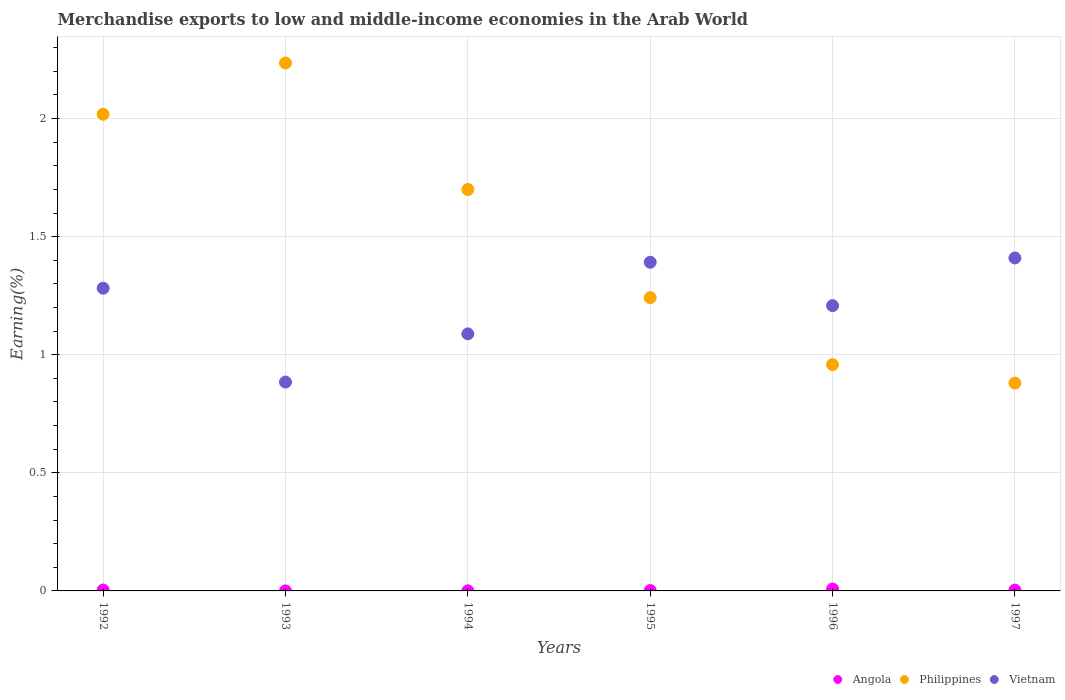How many different coloured dotlines are there?
Provide a succinct answer. 3. What is the percentage of amount earned from merchandise exports in Philippines in 1994?
Give a very brief answer. 1.7. Across all years, what is the maximum percentage of amount earned from merchandise exports in Angola?
Provide a succinct answer. 0.01. Across all years, what is the minimum percentage of amount earned from merchandise exports in Philippines?
Your response must be concise. 0.88. In which year was the percentage of amount earned from merchandise exports in Vietnam maximum?
Ensure brevity in your answer.  1997. What is the total percentage of amount earned from merchandise exports in Angola in the graph?
Offer a very short reply. 0.02. What is the difference between the percentage of amount earned from merchandise exports in Angola in 1992 and that in 1995?
Your response must be concise. 0. What is the difference between the percentage of amount earned from merchandise exports in Angola in 1993 and the percentage of amount earned from merchandise exports in Philippines in 1997?
Provide a short and direct response. -0.88. What is the average percentage of amount earned from merchandise exports in Vietnam per year?
Your answer should be compact. 1.21. In the year 1994, what is the difference between the percentage of amount earned from merchandise exports in Angola and percentage of amount earned from merchandise exports in Philippines?
Keep it short and to the point. -1.7. In how many years, is the percentage of amount earned from merchandise exports in Philippines greater than 1.8 %?
Provide a short and direct response. 2. What is the ratio of the percentage of amount earned from merchandise exports in Philippines in 1994 to that in 1995?
Keep it short and to the point. 1.37. Is the difference between the percentage of amount earned from merchandise exports in Angola in 1992 and 1993 greater than the difference between the percentage of amount earned from merchandise exports in Philippines in 1992 and 1993?
Your answer should be compact. Yes. What is the difference between the highest and the second highest percentage of amount earned from merchandise exports in Vietnam?
Keep it short and to the point. 0.02. What is the difference between the highest and the lowest percentage of amount earned from merchandise exports in Angola?
Ensure brevity in your answer.  0.01. In how many years, is the percentage of amount earned from merchandise exports in Vietnam greater than the average percentage of amount earned from merchandise exports in Vietnam taken over all years?
Provide a short and direct response. 3. Does the percentage of amount earned from merchandise exports in Angola monotonically increase over the years?
Ensure brevity in your answer.  No. Is the percentage of amount earned from merchandise exports in Angola strictly greater than the percentage of amount earned from merchandise exports in Philippines over the years?
Provide a short and direct response. No. How many dotlines are there?
Your answer should be very brief. 3. Does the graph contain any zero values?
Give a very brief answer. No. How many legend labels are there?
Provide a succinct answer. 3. What is the title of the graph?
Ensure brevity in your answer.  Merchandise exports to low and middle-income economies in the Arab World. What is the label or title of the Y-axis?
Provide a succinct answer. Earning(%). What is the Earning(%) in Angola in 1992?
Make the answer very short. 0. What is the Earning(%) in Philippines in 1992?
Offer a very short reply. 2.02. What is the Earning(%) of Vietnam in 1992?
Offer a very short reply. 1.28. What is the Earning(%) of Angola in 1993?
Give a very brief answer. 0. What is the Earning(%) of Philippines in 1993?
Give a very brief answer. 2.24. What is the Earning(%) of Vietnam in 1993?
Your response must be concise. 0.88. What is the Earning(%) of Angola in 1994?
Make the answer very short. 0. What is the Earning(%) in Philippines in 1994?
Offer a very short reply. 1.7. What is the Earning(%) in Vietnam in 1994?
Your answer should be very brief. 1.09. What is the Earning(%) in Angola in 1995?
Your response must be concise. 0. What is the Earning(%) in Philippines in 1995?
Provide a short and direct response. 1.24. What is the Earning(%) in Vietnam in 1995?
Your response must be concise. 1.39. What is the Earning(%) of Angola in 1996?
Give a very brief answer. 0.01. What is the Earning(%) of Philippines in 1996?
Provide a succinct answer. 0.96. What is the Earning(%) in Vietnam in 1996?
Your response must be concise. 1.21. What is the Earning(%) in Angola in 1997?
Provide a short and direct response. 0. What is the Earning(%) in Philippines in 1997?
Your answer should be very brief. 0.88. What is the Earning(%) of Vietnam in 1997?
Your answer should be very brief. 1.41. Across all years, what is the maximum Earning(%) in Angola?
Your answer should be compact. 0.01. Across all years, what is the maximum Earning(%) of Philippines?
Offer a terse response. 2.24. Across all years, what is the maximum Earning(%) in Vietnam?
Ensure brevity in your answer.  1.41. Across all years, what is the minimum Earning(%) in Angola?
Provide a short and direct response. 0. Across all years, what is the minimum Earning(%) in Philippines?
Your response must be concise. 0.88. Across all years, what is the minimum Earning(%) of Vietnam?
Keep it short and to the point. 0.88. What is the total Earning(%) of Angola in the graph?
Keep it short and to the point. 0.02. What is the total Earning(%) of Philippines in the graph?
Provide a short and direct response. 9.03. What is the total Earning(%) of Vietnam in the graph?
Give a very brief answer. 7.26. What is the difference between the Earning(%) of Angola in 1992 and that in 1993?
Give a very brief answer. 0. What is the difference between the Earning(%) of Philippines in 1992 and that in 1993?
Provide a short and direct response. -0.22. What is the difference between the Earning(%) in Vietnam in 1992 and that in 1993?
Provide a short and direct response. 0.4. What is the difference between the Earning(%) in Angola in 1992 and that in 1994?
Provide a short and direct response. 0. What is the difference between the Earning(%) in Philippines in 1992 and that in 1994?
Ensure brevity in your answer.  0.32. What is the difference between the Earning(%) of Vietnam in 1992 and that in 1994?
Your response must be concise. 0.19. What is the difference between the Earning(%) of Angola in 1992 and that in 1995?
Your answer should be very brief. 0. What is the difference between the Earning(%) in Philippines in 1992 and that in 1995?
Your answer should be very brief. 0.78. What is the difference between the Earning(%) in Vietnam in 1992 and that in 1995?
Your response must be concise. -0.11. What is the difference between the Earning(%) in Angola in 1992 and that in 1996?
Provide a short and direct response. -0. What is the difference between the Earning(%) of Philippines in 1992 and that in 1996?
Make the answer very short. 1.06. What is the difference between the Earning(%) in Vietnam in 1992 and that in 1996?
Ensure brevity in your answer.  0.07. What is the difference between the Earning(%) of Philippines in 1992 and that in 1997?
Offer a terse response. 1.14. What is the difference between the Earning(%) of Vietnam in 1992 and that in 1997?
Provide a succinct answer. -0.13. What is the difference between the Earning(%) of Angola in 1993 and that in 1994?
Your answer should be compact. -0. What is the difference between the Earning(%) of Philippines in 1993 and that in 1994?
Your response must be concise. 0.54. What is the difference between the Earning(%) of Vietnam in 1993 and that in 1994?
Offer a very short reply. -0.2. What is the difference between the Earning(%) of Angola in 1993 and that in 1995?
Your response must be concise. -0. What is the difference between the Earning(%) of Philippines in 1993 and that in 1995?
Provide a succinct answer. 0.99. What is the difference between the Earning(%) of Vietnam in 1993 and that in 1995?
Keep it short and to the point. -0.51. What is the difference between the Earning(%) of Angola in 1993 and that in 1996?
Give a very brief answer. -0.01. What is the difference between the Earning(%) in Philippines in 1993 and that in 1996?
Your answer should be compact. 1.28. What is the difference between the Earning(%) in Vietnam in 1993 and that in 1996?
Give a very brief answer. -0.32. What is the difference between the Earning(%) in Angola in 1993 and that in 1997?
Give a very brief answer. -0. What is the difference between the Earning(%) in Philippines in 1993 and that in 1997?
Offer a very short reply. 1.36. What is the difference between the Earning(%) of Vietnam in 1993 and that in 1997?
Your answer should be very brief. -0.53. What is the difference between the Earning(%) of Angola in 1994 and that in 1995?
Your response must be concise. -0. What is the difference between the Earning(%) of Philippines in 1994 and that in 1995?
Provide a succinct answer. 0.46. What is the difference between the Earning(%) of Vietnam in 1994 and that in 1995?
Offer a very short reply. -0.3. What is the difference between the Earning(%) in Angola in 1994 and that in 1996?
Give a very brief answer. -0.01. What is the difference between the Earning(%) of Philippines in 1994 and that in 1996?
Your answer should be compact. 0.74. What is the difference between the Earning(%) in Vietnam in 1994 and that in 1996?
Offer a terse response. -0.12. What is the difference between the Earning(%) of Angola in 1994 and that in 1997?
Provide a short and direct response. -0. What is the difference between the Earning(%) of Philippines in 1994 and that in 1997?
Provide a short and direct response. 0.82. What is the difference between the Earning(%) of Vietnam in 1994 and that in 1997?
Ensure brevity in your answer.  -0.32. What is the difference between the Earning(%) in Angola in 1995 and that in 1996?
Your answer should be compact. -0.01. What is the difference between the Earning(%) of Philippines in 1995 and that in 1996?
Your response must be concise. 0.28. What is the difference between the Earning(%) of Vietnam in 1995 and that in 1996?
Keep it short and to the point. 0.18. What is the difference between the Earning(%) of Angola in 1995 and that in 1997?
Make the answer very short. -0. What is the difference between the Earning(%) of Philippines in 1995 and that in 1997?
Provide a short and direct response. 0.36. What is the difference between the Earning(%) in Vietnam in 1995 and that in 1997?
Provide a short and direct response. -0.02. What is the difference between the Earning(%) of Angola in 1996 and that in 1997?
Provide a short and direct response. 0. What is the difference between the Earning(%) in Philippines in 1996 and that in 1997?
Your answer should be very brief. 0.08. What is the difference between the Earning(%) in Vietnam in 1996 and that in 1997?
Keep it short and to the point. -0.2. What is the difference between the Earning(%) of Angola in 1992 and the Earning(%) of Philippines in 1993?
Make the answer very short. -2.23. What is the difference between the Earning(%) of Angola in 1992 and the Earning(%) of Vietnam in 1993?
Your response must be concise. -0.88. What is the difference between the Earning(%) in Philippines in 1992 and the Earning(%) in Vietnam in 1993?
Ensure brevity in your answer.  1.13. What is the difference between the Earning(%) of Angola in 1992 and the Earning(%) of Philippines in 1994?
Your response must be concise. -1.7. What is the difference between the Earning(%) of Angola in 1992 and the Earning(%) of Vietnam in 1994?
Offer a very short reply. -1.08. What is the difference between the Earning(%) of Philippines in 1992 and the Earning(%) of Vietnam in 1994?
Your answer should be compact. 0.93. What is the difference between the Earning(%) in Angola in 1992 and the Earning(%) in Philippines in 1995?
Provide a succinct answer. -1.24. What is the difference between the Earning(%) of Angola in 1992 and the Earning(%) of Vietnam in 1995?
Make the answer very short. -1.39. What is the difference between the Earning(%) of Philippines in 1992 and the Earning(%) of Vietnam in 1995?
Make the answer very short. 0.63. What is the difference between the Earning(%) of Angola in 1992 and the Earning(%) of Philippines in 1996?
Offer a very short reply. -0.95. What is the difference between the Earning(%) in Angola in 1992 and the Earning(%) in Vietnam in 1996?
Keep it short and to the point. -1.2. What is the difference between the Earning(%) of Philippines in 1992 and the Earning(%) of Vietnam in 1996?
Make the answer very short. 0.81. What is the difference between the Earning(%) in Angola in 1992 and the Earning(%) in Philippines in 1997?
Make the answer very short. -0.88. What is the difference between the Earning(%) in Angola in 1992 and the Earning(%) in Vietnam in 1997?
Offer a terse response. -1.41. What is the difference between the Earning(%) of Philippines in 1992 and the Earning(%) of Vietnam in 1997?
Offer a terse response. 0.61. What is the difference between the Earning(%) of Angola in 1993 and the Earning(%) of Philippines in 1994?
Offer a very short reply. -1.7. What is the difference between the Earning(%) of Angola in 1993 and the Earning(%) of Vietnam in 1994?
Keep it short and to the point. -1.09. What is the difference between the Earning(%) in Philippines in 1993 and the Earning(%) in Vietnam in 1994?
Keep it short and to the point. 1.15. What is the difference between the Earning(%) in Angola in 1993 and the Earning(%) in Philippines in 1995?
Keep it short and to the point. -1.24. What is the difference between the Earning(%) of Angola in 1993 and the Earning(%) of Vietnam in 1995?
Offer a very short reply. -1.39. What is the difference between the Earning(%) in Philippines in 1993 and the Earning(%) in Vietnam in 1995?
Provide a succinct answer. 0.84. What is the difference between the Earning(%) in Angola in 1993 and the Earning(%) in Philippines in 1996?
Your answer should be very brief. -0.96. What is the difference between the Earning(%) in Angola in 1993 and the Earning(%) in Vietnam in 1996?
Your answer should be very brief. -1.21. What is the difference between the Earning(%) in Philippines in 1993 and the Earning(%) in Vietnam in 1996?
Offer a very short reply. 1.03. What is the difference between the Earning(%) in Angola in 1993 and the Earning(%) in Philippines in 1997?
Your answer should be very brief. -0.88. What is the difference between the Earning(%) in Angola in 1993 and the Earning(%) in Vietnam in 1997?
Provide a succinct answer. -1.41. What is the difference between the Earning(%) of Philippines in 1993 and the Earning(%) of Vietnam in 1997?
Offer a very short reply. 0.83. What is the difference between the Earning(%) of Angola in 1994 and the Earning(%) of Philippines in 1995?
Offer a terse response. -1.24. What is the difference between the Earning(%) of Angola in 1994 and the Earning(%) of Vietnam in 1995?
Make the answer very short. -1.39. What is the difference between the Earning(%) of Philippines in 1994 and the Earning(%) of Vietnam in 1995?
Keep it short and to the point. 0.31. What is the difference between the Earning(%) of Angola in 1994 and the Earning(%) of Philippines in 1996?
Your answer should be compact. -0.96. What is the difference between the Earning(%) in Angola in 1994 and the Earning(%) in Vietnam in 1996?
Your answer should be very brief. -1.21. What is the difference between the Earning(%) of Philippines in 1994 and the Earning(%) of Vietnam in 1996?
Your answer should be compact. 0.49. What is the difference between the Earning(%) of Angola in 1994 and the Earning(%) of Philippines in 1997?
Provide a short and direct response. -0.88. What is the difference between the Earning(%) of Angola in 1994 and the Earning(%) of Vietnam in 1997?
Offer a terse response. -1.41. What is the difference between the Earning(%) in Philippines in 1994 and the Earning(%) in Vietnam in 1997?
Provide a succinct answer. 0.29. What is the difference between the Earning(%) in Angola in 1995 and the Earning(%) in Philippines in 1996?
Offer a terse response. -0.96. What is the difference between the Earning(%) in Angola in 1995 and the Earning(%) in Vietnam in 1996?
Ensure brevity in your answer.  -1.21. What is the difference between the Earning(%) in Philippines in 1995 and the Earning(%) in Vietnam in 1996?
Offer a terse response. 0.03. What is the difference between the Earning(%) in Angola in 1995 and the Earning(%) in Philippines in 1997?
Make the answer very short. -0.88. What is the difference between the Earning(%) of Angola in 1995 and the Earning(%) of Vietnam in 1997?
Provide a succinct answer. -1.41. What is the difference between the Earning(%) of Philippines in 1995 and the Earning(%) of Vietnam in 1997?
Offer a terse response. -0.17. What is the difference between the Earning(%) of Angola in 1996 and the Earning(%) of Philippines in 1997?
Offer a very short reply. -0.87. What is the difference between the Earning(%) of Angola in 1996 and the Earning(%) of Vietnam in 1997?
Make the answer very short. -1.4. What is the difference between the Earning(%) in Philippines in 1996 and the Earning(%) in Vietnam in 1997?
Keep it short and to the point. -0.45. What is the average Earning(%) of Angola per year?
Provide a succinct answer. 0. What is the average Earning(%) of Philippines per year?
Your response must be concise. 1.51. What is the average Earning(%) of Vietnam per year?
Offer a terse response. 1.21. In the year 1992, what is the difference between the Earning(%) of Angola and Earning(%) of Philippines?
Your response must be concise. -2.01. In the year 1992, what is the difference between the Earning(%) of Angola and Earning(%) of Vietnam?
Your answer should be very brief. -1.28. In the year 1992, what is the difference between the Earning(%) of Philippines and Earning(%) of Vietnam?
Give a very brief answer. 0.74. In the year 1993, what is the difference between the Earning(%) in Angola and Earning(%) in Philippines?
Your answer should be very brief. -2.24. In the year 1993, what is the difference between the Earning(%) of Angola and Earning(%) of Vietnam?
Your response must be concise. -0.88. In the year 1993, what is the difference between the Earning(%) in Philippines and Earning(%) in Vietnam?
Your response must be concise. 1.35. In the year 1994, what is the difference between the Earning(%) of Angola and Earning(%) of Philippines?
Give a very brief answer. -1.7. In the year 1994, what is the difference between the Earning(%) in Angola and Earning(%) in Vietnam?
Provide a succinct answer. -1.09. In the year 1994, what is the difference between the Earning(%) of Philippines and Earning(%) of Vietnam?
Your answer should be very brief. 0.61. In the year 1995, what is the difference between the Earning(%) of Angola and Earning(%) of Philippines?
Provide a short and direct response. -1.24. In the year 1995, what is the difference between the Earning(%) of Angola and Earning(%) of Vietnam?
Make the answer very short. -1.39. In the year 1995, what is the difference between the Earning(%) in Philippines and Earning(%) in Vietnam?
Offer a terse response. -0.15. In the year 1996, what is the difference between the Earning(%) of Angola and Earning(%) of Philippines?
Give a very brief answer. -0.95. In the year 1996, what is the difference between the Earning(%) of Angola and Earning(%) of Vietnam?
Provide a short and direct response. -1.2. In the year 1996, what is the difference between the Earning(%) in Philippines and Earning(%) in Vietnam?
Ensure brevity in your answer.  -0.25. In the year 1997, what is the difference between the Earning(%) in Angola and Earning(%) in Philippines?
Offer a very short reply. -0.88. In the year 1997, what is the difference between the Earning(%) in Angola and Earning(%) in Vietnam?
Make the answer very short. -1.41. In the year 1997, what is the difference between the Earning(%) of Philippines and Earning(%) of Vietnam?
Your answer should be very brief. -0.53. What is the ratio of the Earning(%) in Angola in 1992 to that in 1993?
Provide a short and direct response. 34.95. What is the ratio of the Earning(%) of Philippines in 1992 to that in 1993?
Offer a very short reply. 0.9. What is the ratio of the Earning(%) of Vietnam in 1992 to that in 1993?
Your answer should be compact. 1.45. What is the ratio of the Earning(%) of Angola in 1992 to that in 1994?
Provide a succinct answer. 11.24. What is the ratio of the Earning(%) in Philippines in 1992 to that in 1994?
Keep it short and to the point. 1.19. What is the ratio of the Earning(%) of Vietnam in 1992 to that in 1994?
Keep it short and to the point. 1.18. What is the ratio of the Earning(%) of Angola in 1992 to that in 1995?
Offer a terse response. 2.59. What is the ratio of the Earning(%) in Philippines in 1992 to that in 1995?
Offer a very short reply. 1.63. What is the ratio of the Earning(%) in Vietnam in 1992 to that in 1995?
Give a very brief answer. 0.92. What is the ratio of the Earning(%) in Angola in 1992 to that in 1996?
Provide a succinct answer. 0.47. What is the ratio of the Earning(%) of Philippines in 1992 to that in 1996?
Ensure brevity in your answer.  2.11. What is the ratio of the Earning(%) of Vietnam in 1992 to that in 1996?
Your answer should be compact. 1.06. What is the ratio of the Earning(%) of Angola in 1992 to that in 1997?
Your answer should be compact. 1.11. What is the ratio of the Earning(%) of Philippines in 1992 to that in 1997?
Provide a short and direct response. 2.29. What is the ratio of the Earning(%) of Vietnam in 1992 to that in 1997?
Provide a short and direct response. 0.91. What is the ratio of the Earning(%) in Angola in 1993 to that in 1994?
Provide a short and direct response. 0.32. What is the ratio of the Earning(%) in Philippines in 1993 to that in 1994?
Offer a very short reply. 1.32. What is the ratio of the Earning(%) in Vietnam in 1993 to that in 1994?
Provide a short and direct response. 0.81. What is the ratio of the Earning(%) in Angola in 1993 to that in 1995?
Make the answer very short. 0.07. What is the ratio of the Earning(%) of Philippines in 1993 to that in 1995?
Offer a very short reply. 1.8. What is the ratio of the Earning(%) of Vietnam in 1993 to that in 1995?
Your answer should be compact. 0.64. What is the ratio of the Earning(%) in Angola in 1993 to that in 1996?
Provide a short and direct response. 0.01. What is the ratio of the Earning(%) in Philippines in 1993 to that in 1996?
Your answer should be compact. 2.33. What is the ratio of the Earning(%) in Vietnam in 1993 to that in 1996?
Your answer should be compact. 0.73. What is the ratio of the Earning(%) of Angola in 1993 to that in 1997?
Make the answer very short. 0.03. What is the ratio of the Earning(%) in Philippines in 1993 to that in 1997?
Your response must be concise. 2.54. What is the ratio of the Earning(%) in Vietnam in 1993 to that in 1997?
Ensure brevity in your answer.  0.63. What is the ratio of the Earning(%) in Angola in 1994 to that in 1995?
Your answer should be compact. 0.23. What is the ratio of the Earning(%) of Philippines in 1994 to that in 1995?
Your answer should be compact. 1.37. What is the ratio of the Earning(%) in Vietnam in 1994 to that in 1995?
Give a very brief answer. 0.78. What is the ratio of the Earning(%) in Angola in 1994 to that in 1996?
Provide a succinct answer. 0.04. What is the ratio of the Earning(%) of Philippines in 1994 to that in 1996?
Provide a short and direct response. 1.77. What is the ratio of the Earning(%) of Vietnam in 1994 to that in 1996?
Offer a terse response. 0.9. What is the ratio of the Earning(%) of Angola in 1994 to that in 1997?
Your response must be concise. 0.1. What is the ratio of the Earning(%) in Philippines in 1994 to that in 1997?
Ensure brevity in your answer.  1.93. What is the ratio of the Earning(%) of Vietnam in 1994 to that in 1997?
Your answer should be compact. 0.77. What is the ratio of the Earning(%) of Angola in 1995 to that in 1996?
Provide a succinct answer. 0.18. What is the ratio of the Earning(%) in Philippines in 1995 to that in 1996?
Ensure brevity in your answer.  1.3. What is the ratio of the Earning(%) in Vietnam in 1995 to that in 1996?
Give a very brief answer. 1.15. What is the ratio of the Earning(%) in Angola in 1995 to that in 1997?
Offer a terse response. 0.43. What is the ratio of the Earning(%) of Philippines in 1995 to that in 1997?
Provide a short and direct response. 1.41. What is the ratio of the Earning(%) of Vietnam in 1995 to that in 1997?
Provide a short and direct response. 0.99. What is the ratio of the Earning(%) in Angola in 1996 to that in 1997?
Provide a short and direct response. 2.34. What is the ratio of the Earning(%) in Philippines in 1996 to that in 1997?
Provide a succinct answer. 1.09. What is the ratio of the Earning(%) of Vietnam in 1996 to that in 1997?
Give a very brief answer. 0.86. What is the difference between the highest and the second highest Earning(%) in Angola?
Make the answer very short. 0. What is the difference between the highest and the second highest Earning(%) in Philippines?
Offer a very short reply. 0.22. What is the difference between the highest and the second highest Earning(%) of Vietnam?
Your answer should be very brief. 0.02. What is the difference between the highest and the lowest Earning(%) of Angola?
Your answer should be compact. 0.01. What is the difference between the highest and the lowest Earning(%) in Philippines?
Provide a short and direct response. 1.36. What is the difference between the highest and the lowest Earning(%) of Vietnam?
Your answer should be very brief. 0.53. 